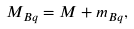Convert formula to latex. <formula><loc_0><loc_0><loc_500><loc_500>M _ { B q } = M + m _ { B q } ,</formula> 